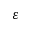Convert formula to latex. <formula><loc_0><loc_0><loc_500><loc_500>\varepsilon</formula> 